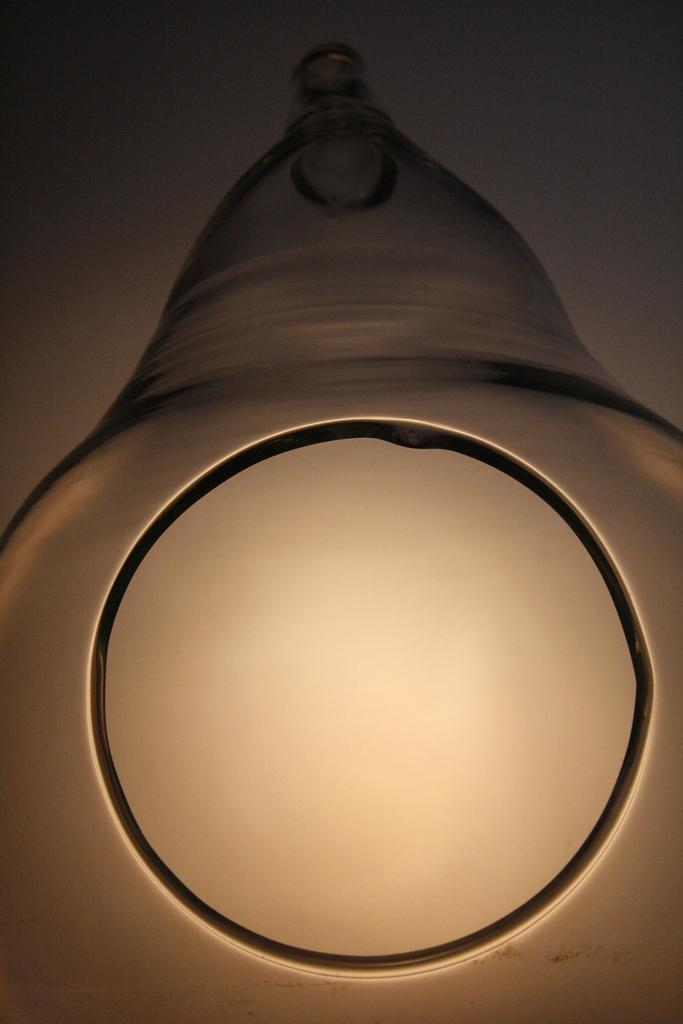What can be seen in the image that emits light? There is a light in the image. How is the light shaped? The light is in a circle shape. What is located above the light? There is an object above the light. What is the mass of the zephyr in the image? There is no zephyr present in the image, as a zephyr refers to a gentle breeze and is not a physical object that can have mass. 